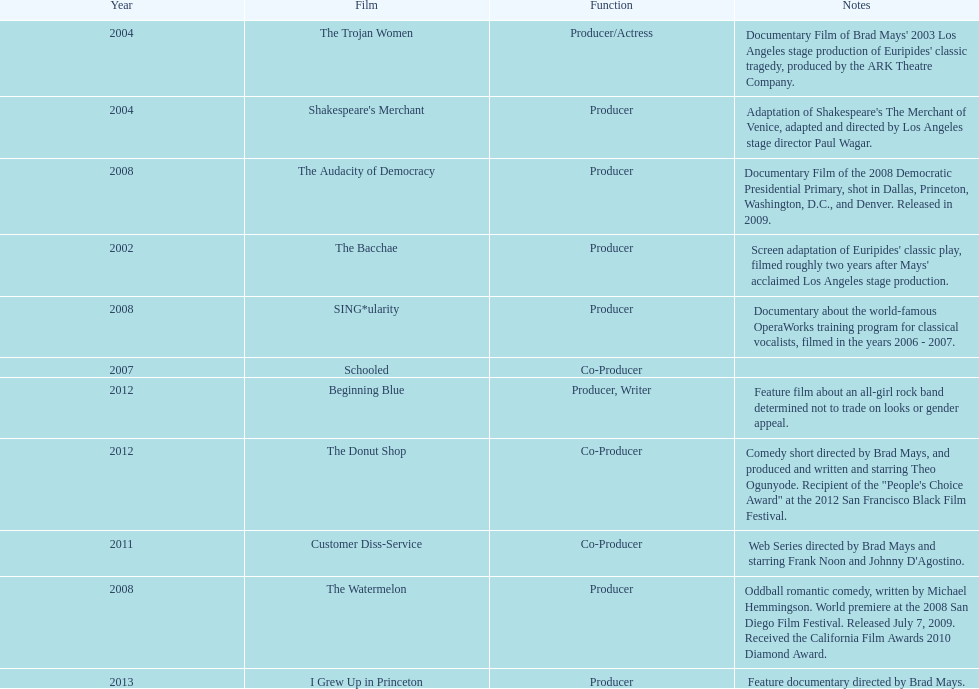What documentary motion picture was made before 2011 but following 2008? The Audacity of Democracy. 